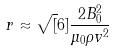Convert formula to latex. <formula><loc_0><loc_0><loc_500><loc_500>r \approx \sqrt { [ } 6 ] { \frac { 2 B _ { 0 } ^ { 2 } } { \mu _ { 0 } \rho v ^ { 2 } } }</formula> 